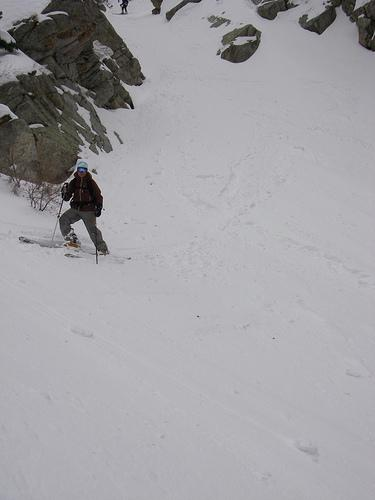Question: who is wearing goggles?
Choices:
A. The scientist.
B. The person skiing.
C. The scuba diver.
D. The welder.
Answer with the letter. Answer: B Question: where are the rocks?
Choices:
A. Behind the man.
B. In front of the man.
C. Under the man.
D. To the left of the man.
Answer with the letter. Answer: A Question: what color pants is the man wearing?
Choices:
A. Gray.
B. White.
C. Black.
D. Yellow.
Answer with the letter. Answer: A Question: what is the man doing?
Choices:
A. Skiing.
B. Swimming.
C. Dancing.
D. Fishing.
Answer with the letter. Answer: A 